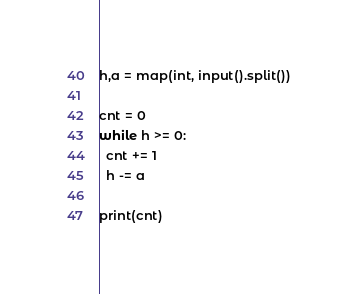Convert code to text. <code><loc_0><loc_0><loc_500><loc_500><_Python_>h,a = map(int, input().split())

cnt = 0
while h >= 0:
  cnt += 1
  h -= a

print(cnt)</code> 